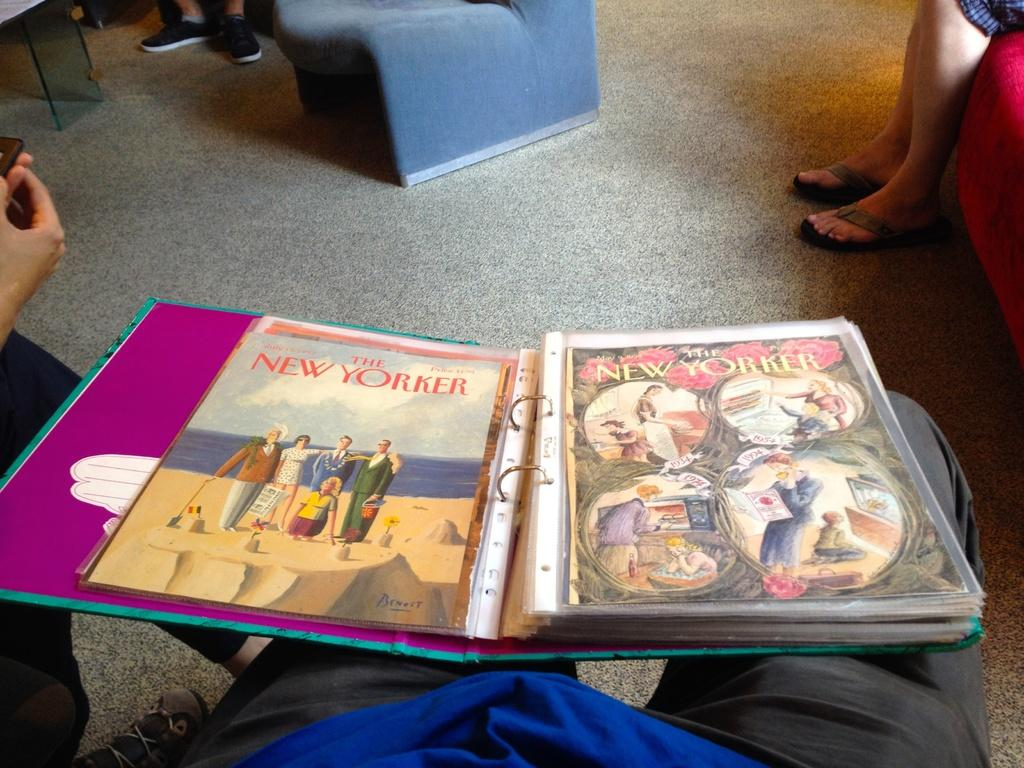<image>
Share a concise interpretation of the image provided. a magazine with New Yorker written on it 